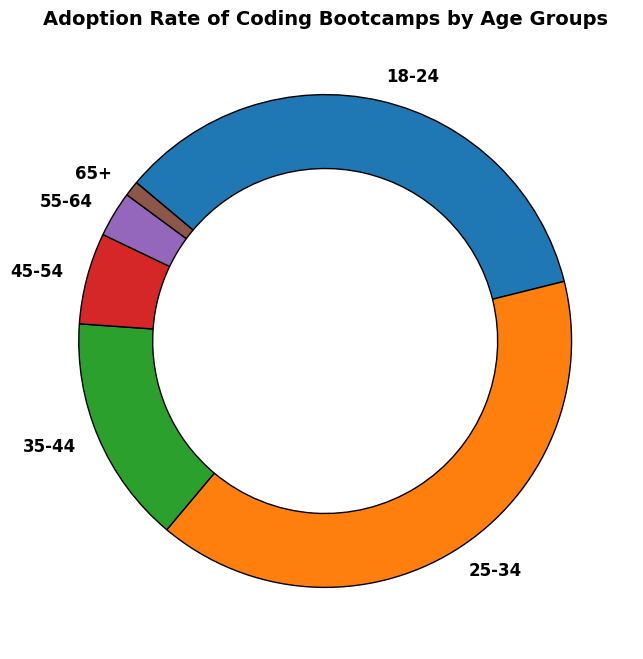What is the adoption rate for the age group 25-34? Look at the label corresponding to the age group 25-34, which shows the adoption rate.
Answer: 40% Which age group has the lowest adoption rate? Identify the label with the smallest percentage.
Answer: 65+ What is the combined adoption rate of age groups 18-24 and 25-34? Sum the percentages of adoption rates for age groups 18-24 and 25-34. 35% + 40% = 75%
Answer: 75% How much higher is the adoption rate of the age group 25-34 compared to 35-44? Find the difference between the adoption rates of age groups 25-34 and 35-44. 40% - 15% = 25%
Answer: 25% Is the adoption rate of coding bootcamps higher for age group 18-24 or 45-54? Compare the adoption rates of age groups 18-24 and 45-54. 35% vs 6%.
Answer: 18-24 Which age group shows an adoption rate higher than 20%? Identify the age group labels with percentages greater than 20%.
Answer: 18-24, 25-34 Are there more age groups with adoption rates below 10% or above 10%? Count the number of age groups with adoption rates below and above 10%. Below: 3 (45-54, 55-64, 65+), Above: 3 (18-24, 25-34, 35-44)
Answer: They are equal How much more popular are coding bootcamps with the 18-24 age group compared to the 55-64 age group? Find the difference in adoption rates between the 18-24 and 55-64 age groups. 35% - 3% = 32%
Answer: 32% What is the average adoption rate of all age groups above 44? Calculate the average of the adoption rates for age groups 45-54, 55-64, and 65+. (6% + 3% + 1%) / 3 = 10% / 3 ≈ 3.33%
Answer: 3.33% If the combined adoption rate of all groups is considered 100%, what fraction does the age group 35-44 contribute? The fraction contributed by an age group is its adoption rate divided by 100%. 15% / 100% = 0.15 or 15/100
Answer: 0.15 or 15/100 